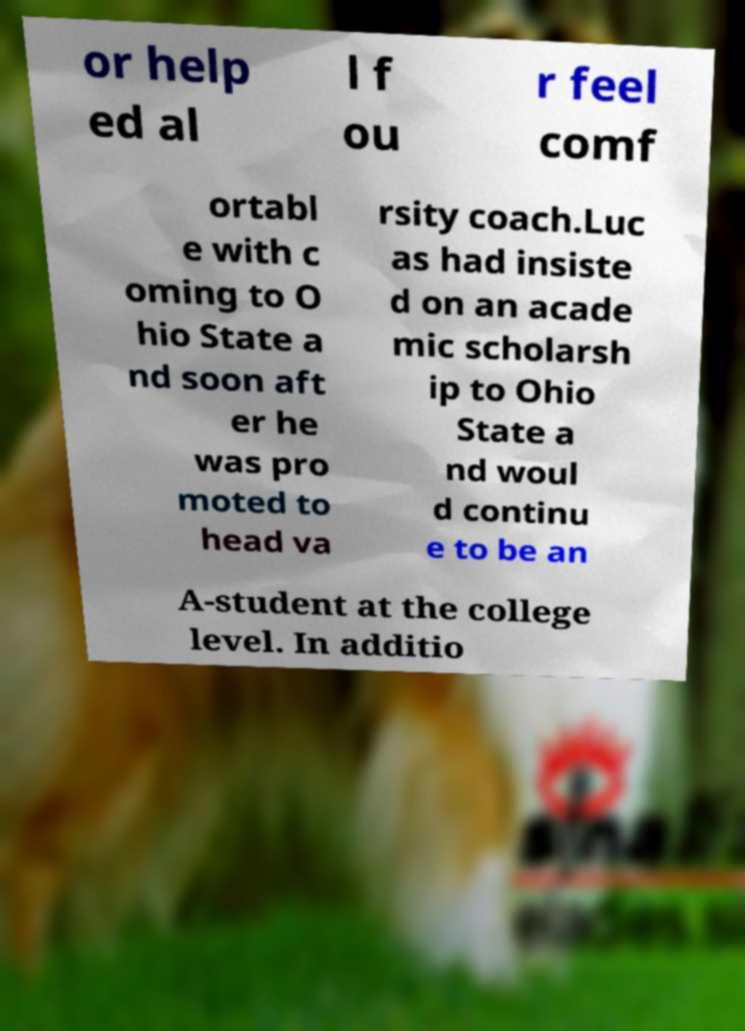I need the written content from this picture converted into text. Can you do that? or help ed al l f ou r feel comf ortabl e with c oming to O hio State a nd soon aft er he was pro moted to head va rsity coach.Luc as had insiste d on an acade mic scholarsh ip to Ohio State a nd woul d continu e to be an A-student at the college level. In additio 